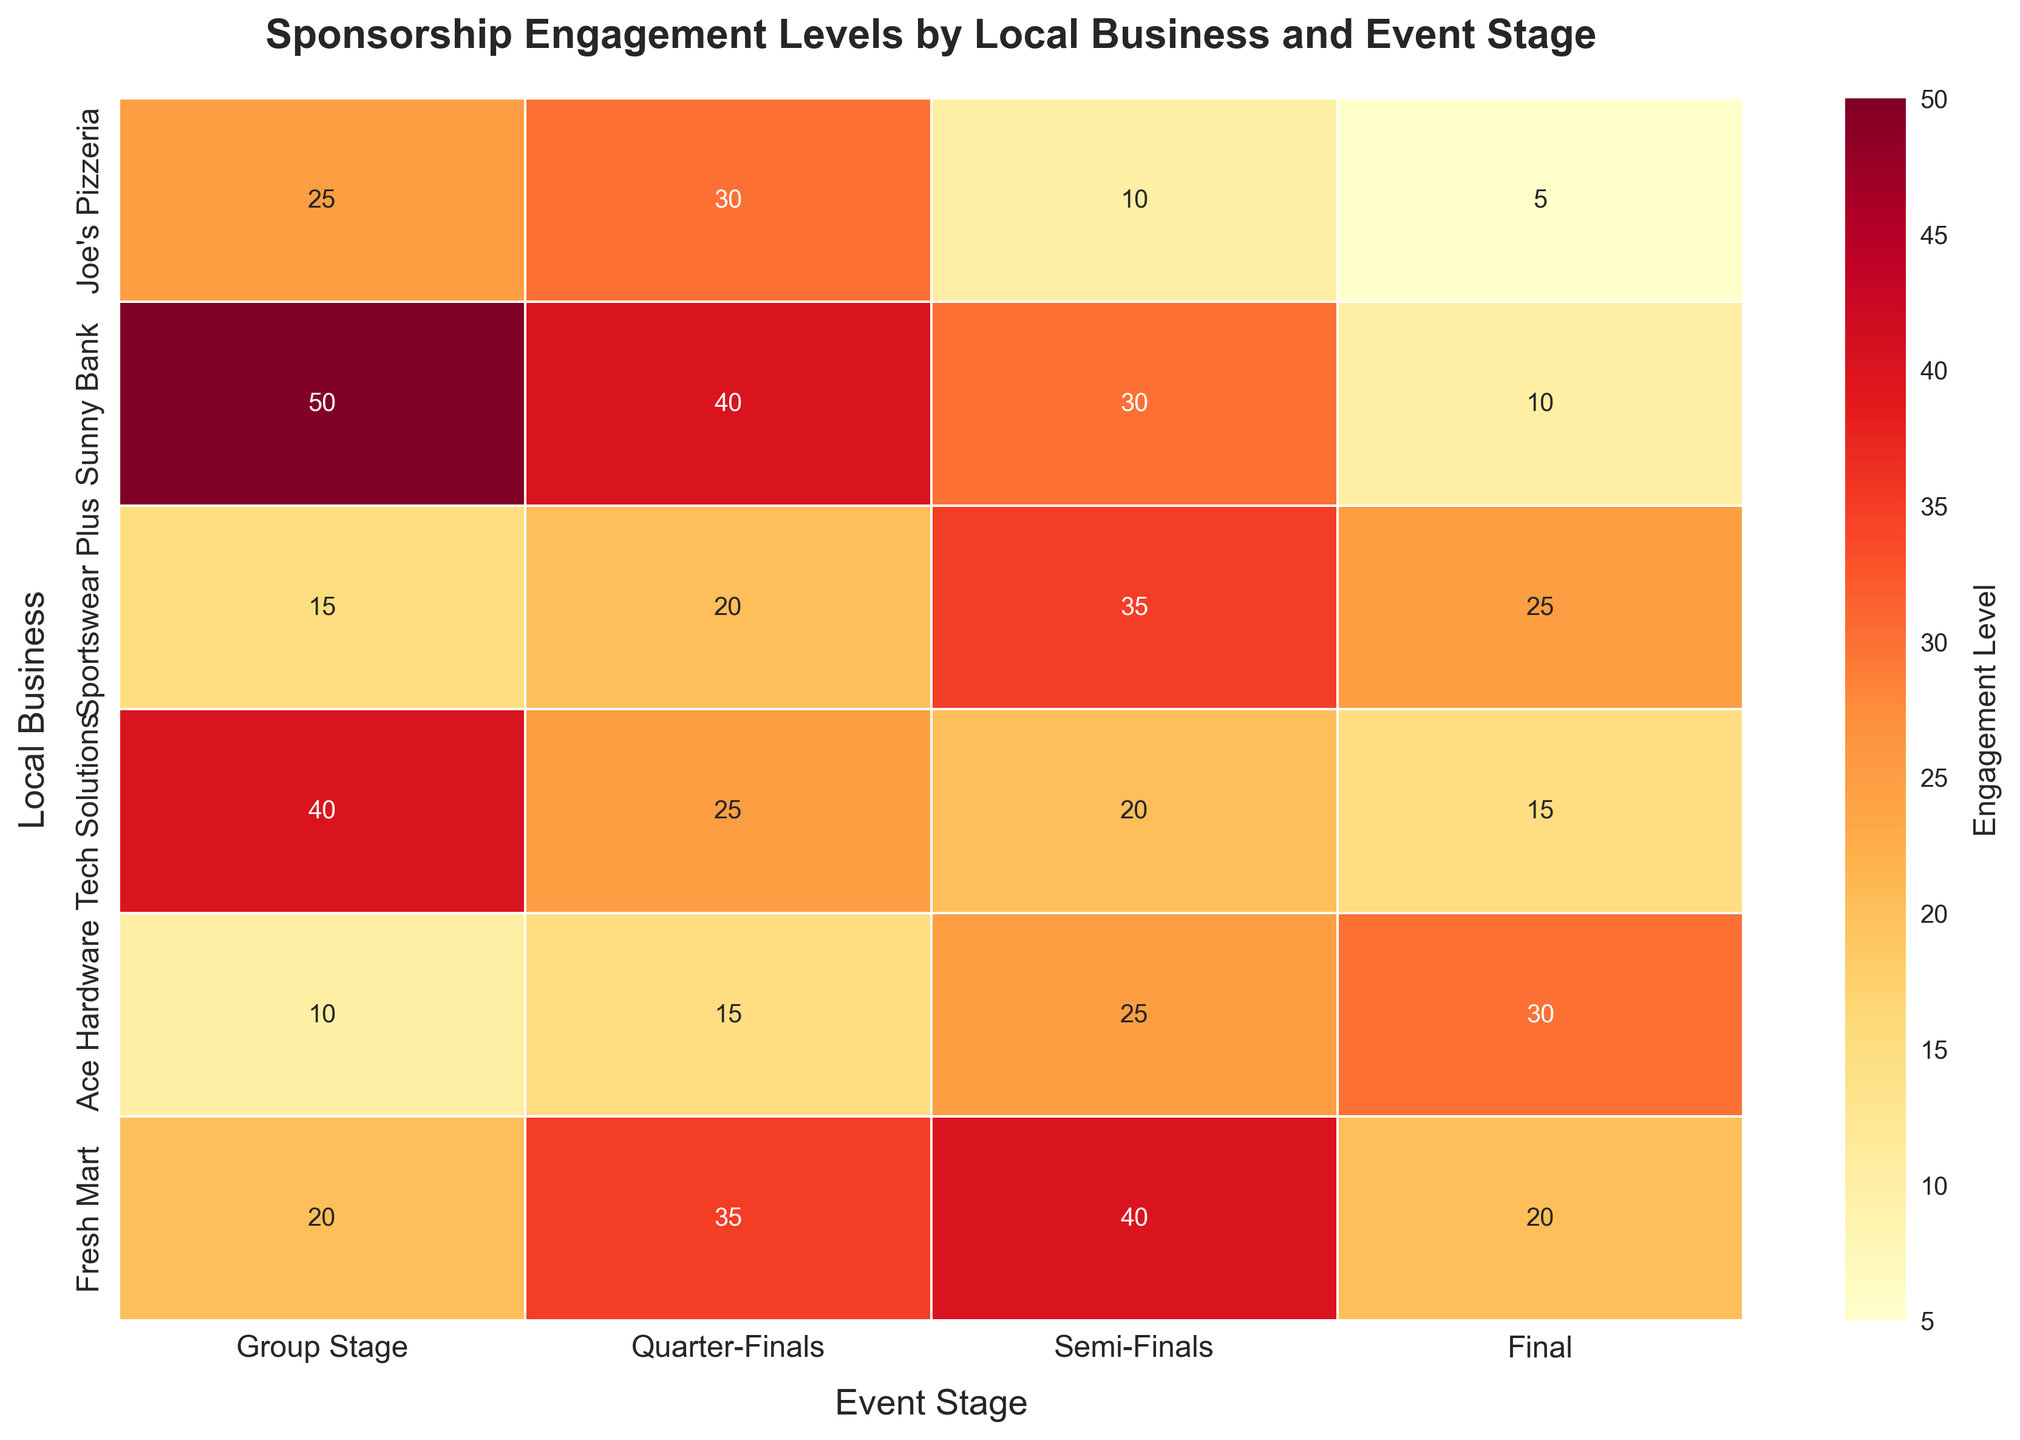what is the title of the heatmap? The title is found at the top center of the figure. It describes the overall purpose of the heatmap, explaining what data is being visualized.
Answer: Sponsorship Engagement Levels by Local Business and Event Stage Which sponsor has the highest engagement level in the Semi-Finals stage? Look at the column labeled 'Semi-Finals'. Find the row with the highest number in that column.
Answer: Fresh Mart How many different sponsors are shown in the heatmap? Count the number of unique rows in the heatmap, each representing a different sponsor.
Answer: 6 What is the average engagement level of Sunny Bank across all stages? Sum the engagement levels of Sunny Bank for all stages and divide by the number of stages. Sunny Bank's engagement levels are [50, 40, 30, 10]. So, (50+40+30+10)/4 = 32.5
Answer: 32.5 Compare the engagement levels of Joe's Pizzeria and Ace Hardware in the Final stage. Which one is higher? Look at the 'Final' column for both Joe's Pizzeria and Ace Hardware. Compare the two numbers. Joe's Pizzeria has 5 and Ace Hardware has 30.
Answer: Ace Hardware Which stage shows the highest overall engagement level for Tech Solutions, and what is that level? Find the highest number in the row for Tech Solutions and note the corresponding column header. Tech Solutions' engagement levels are [40, 25, 20, 15], with the highest being 40 in the Group Stage.
Answer: Group Stage, 40 Sum the engagement levels of Sportswear Plus and Fresh Mart in the Group Stage. Add the engagement levels of Sportswear Plus and Fresh Mart in the Group Stage. Sportswear Plus has 15 and Fresh Mart has 20. So, 15 + 20 = 35.
Answer: 35 Which stage has the lowest engagement level across all sponsors? Find the smallest number in the entire heatmap and note the corresponding column. The smallest engagement level is 5, which is in the 'Final' column.
Answer: Final Calculate the difference in engagement levels between the Group Stage and Quarter-Finals for Joe's Pizzeria. Subtract Joe's Pizzeria's engagement level in the Group Stage from the engagement level in the Quarter-Finals. The values are 25 (Group Stage) and 30 (Quarter-Finals). So, 30 - 25 = 5.
Answer: 5 Which sponsor has the most balanced engagement levels across all stages, and what does "balanced" mean in this context? Look at each sponsor's row and find the one with the smallest range between the highest and lowest values. "Balanced" means that the engagement levels don't vary much between stages. The sponsor with the most balanced engagement levels typically has close numbers for each stage. For this heatmap, Tech Solutions has engagement levels [40, 25, 20, 15], making it one of the more balanced sponsors.
Answer: Tech Solutions 